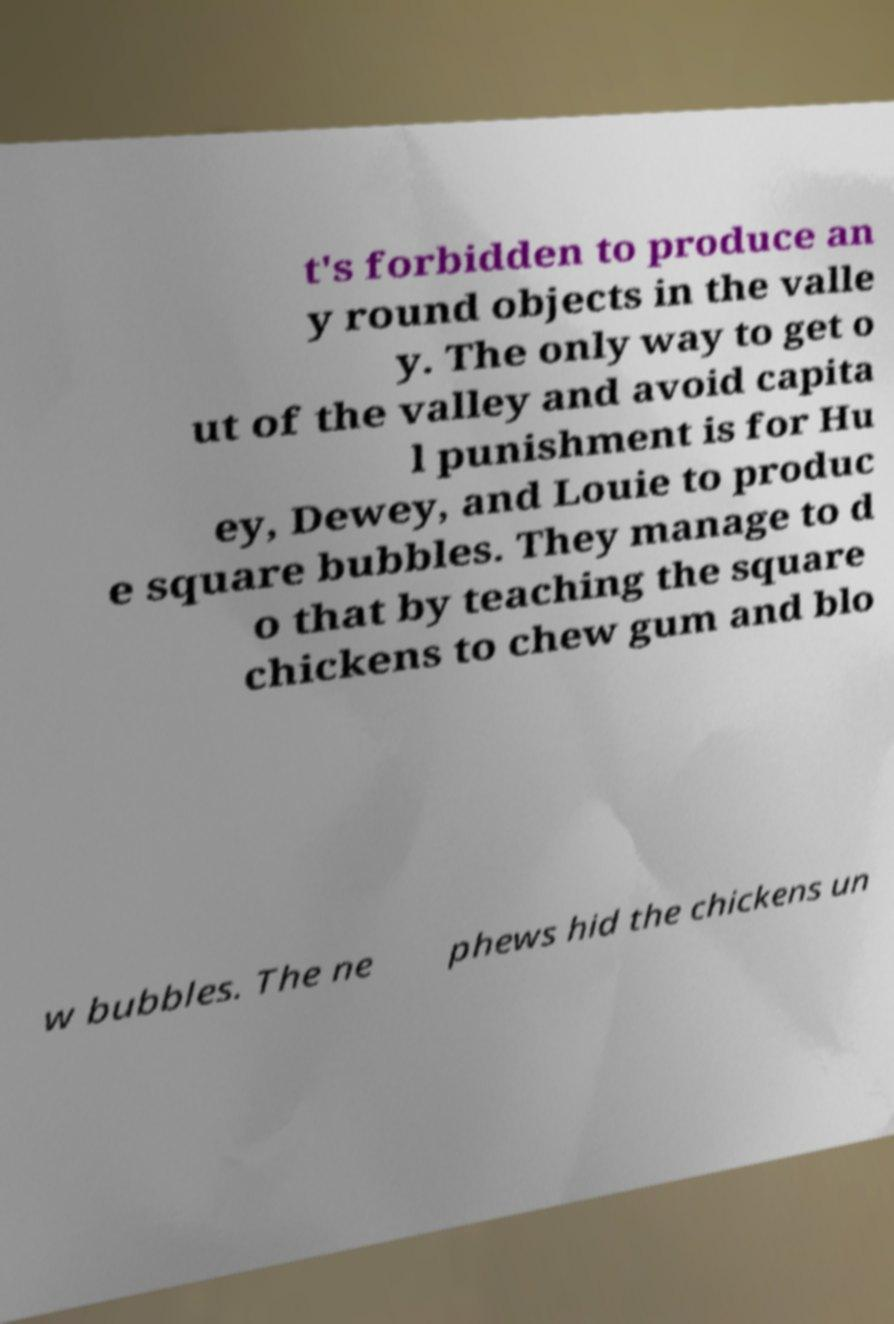There's text embedded in this image that I need extracted. Can you transcribe it verbatim? t's forbidden to produce an y round objects in the valle y. The only way to get o ut of the valley and avoid capita l punishment is for Hu ey, Dewey, and Louie to produc e square bubbles. They manage to d o that by teaching the square chickens to chew gum and blo w bubbles. The ne phews hid the chickens un 